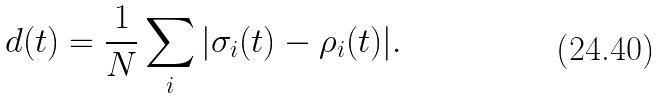<formula> <loc_0><loc_0><loc_500><loc_500>d ( t ) = \frac { 1 } { N } \sum _ { i } | \sigma _ { i } ( t ) - \rho _ { i } ( t ) | .</formula> 